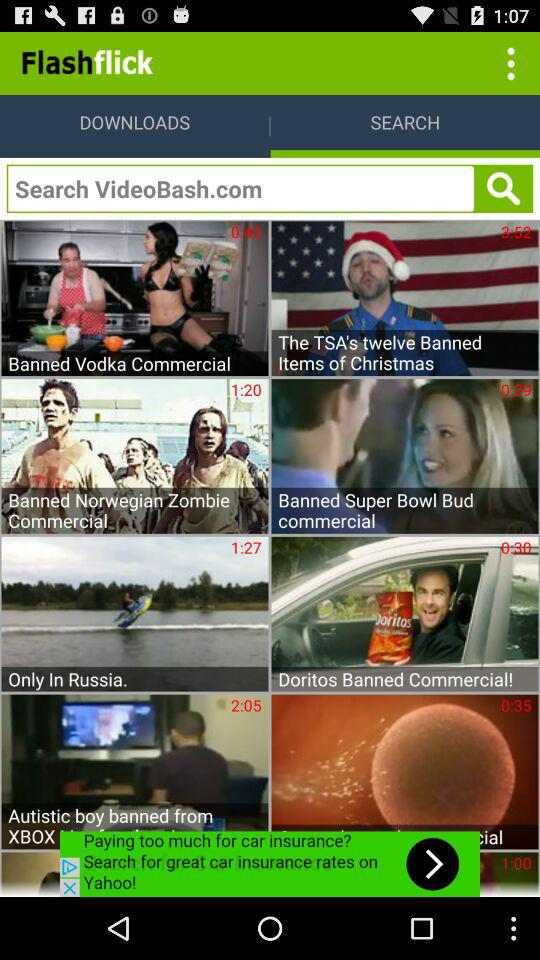What is the duration of the video titled "Only In Russia"? The duration of the video titled "Only In Russia" is 1 minute 27 seconds. 